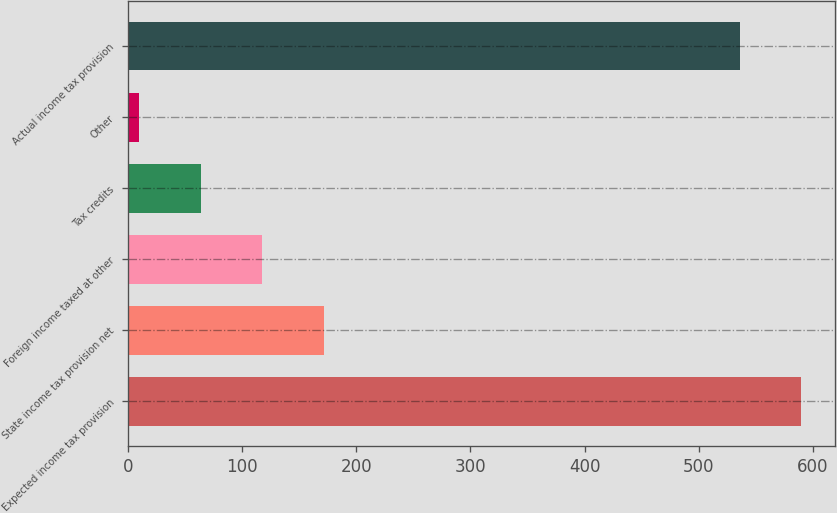Convert chart. <chart><loc_0><loc_0><loc_500><loc_500><bar_chart><fcel>Expected income tax provision<fcel>State income tax provision net<fcel>Foreign income taxed at other<fcel>Tax credits<fcel>Other<fcel>Actual income tax provision<nl><fcel>589.8<fcel>171.4<fcel>117.6<fcel>63.8<fcel>10<fcel>536<nl></chart> 